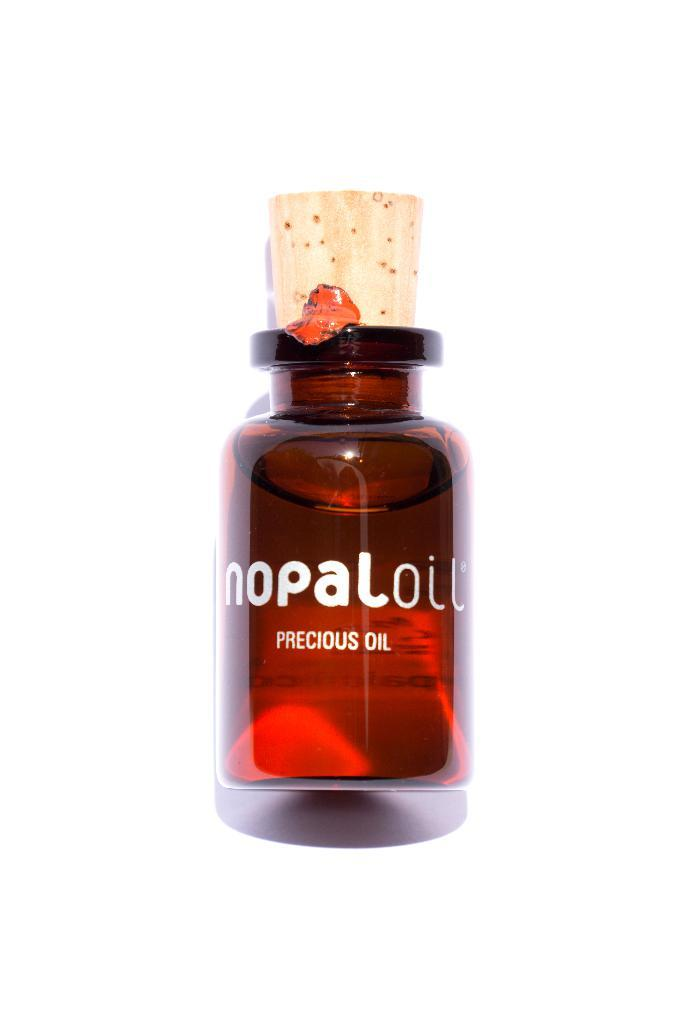<image>
Share a concise interpretation of the image provided. a close up of a glass of Precious Oil with a cork top 